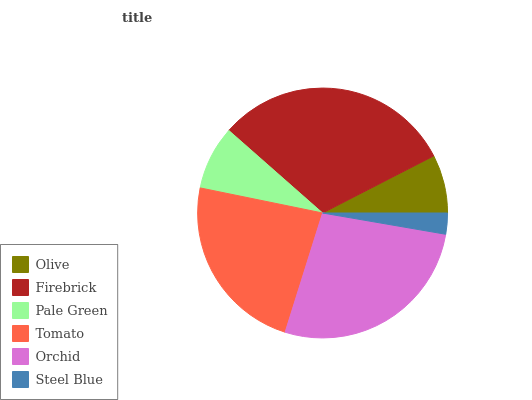Is Steel Blue the minimum?
Answer yes or no. Yes. Is Firebrick the maximum?
Answer yes or no. Yes. Is Pale Green the minimum?
Answer yes or no. No. Is Pale Green the maximum?
Answer yes or no. No. Is Firebrick greater than Pale Green?
Answer yes or no. Yes. Is Pale Green less than Firebrick?
Answer yes or no. Yes. Is Pale Green greater than Firebrick?
Answer yes or no. No. Is Firebrick less than Pale Green?
Answer yes or no. No. Is Tomato the high median?
Answer yes or no. Yes. Is Pale Green the low median?
Answer yes or no. Yes. Is Olive the high median?
Answer yes or no. No. Is Olive the low median?
Answer yes or no. No. 